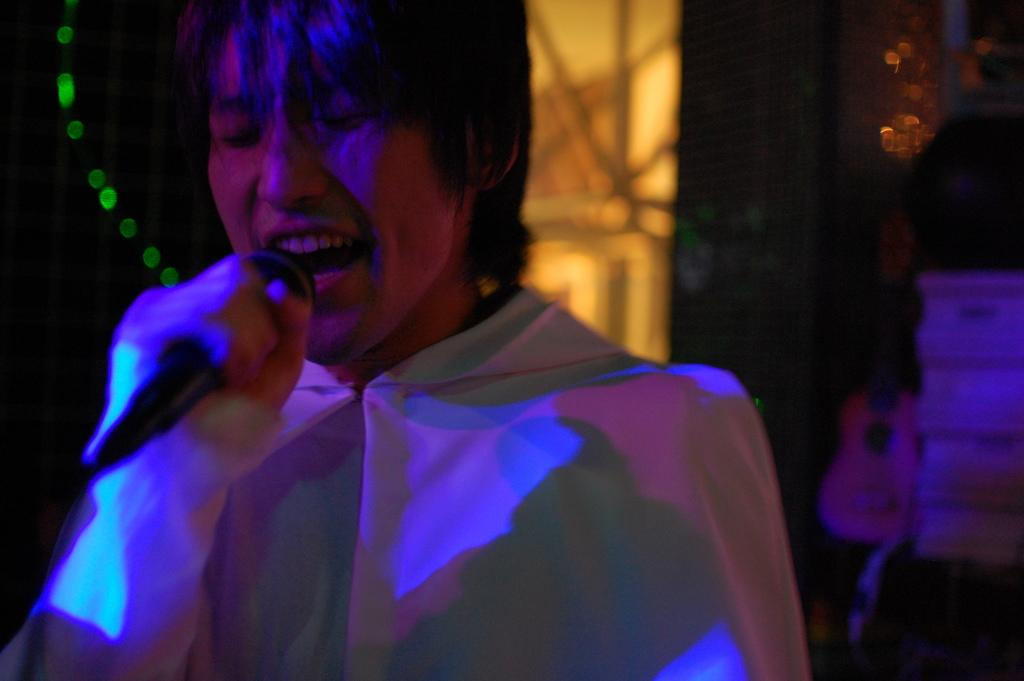Who is the main subject in the image? There is a person in the image. What is the person holding in the image? The person is holding a mic. What is the person doing with the mic? The person is singing. What can be seen in the background of the image? There are lights and a guitar visible in the background. How would you describe the lighting in the image? The background of the image is dark. What type of mask is the person wearing while singing in the image? There is no mask visible in the image; the person is not wearing one. How does the stone contribute to the person's singing performance in the image? There is no stone present in the image, so it cannot contribute to the person's singing performance. 